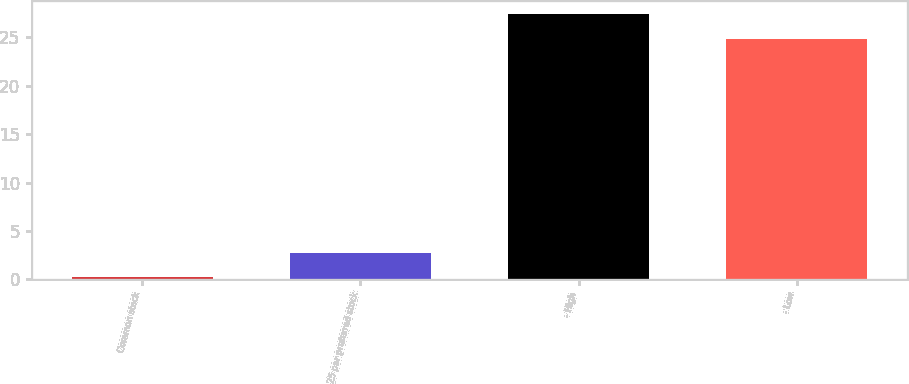Convert chart to OTSL. <chart><loc_0><loc_0><loc_500><loc_500><bar_chart><fcel>Common stock<fcel>25 par preferred stock<fcel>- High<fcel>- Low<nl><fcel>0.2<fcel>2.78<fcel>27.39<fcel>24.81<nl></chart> 